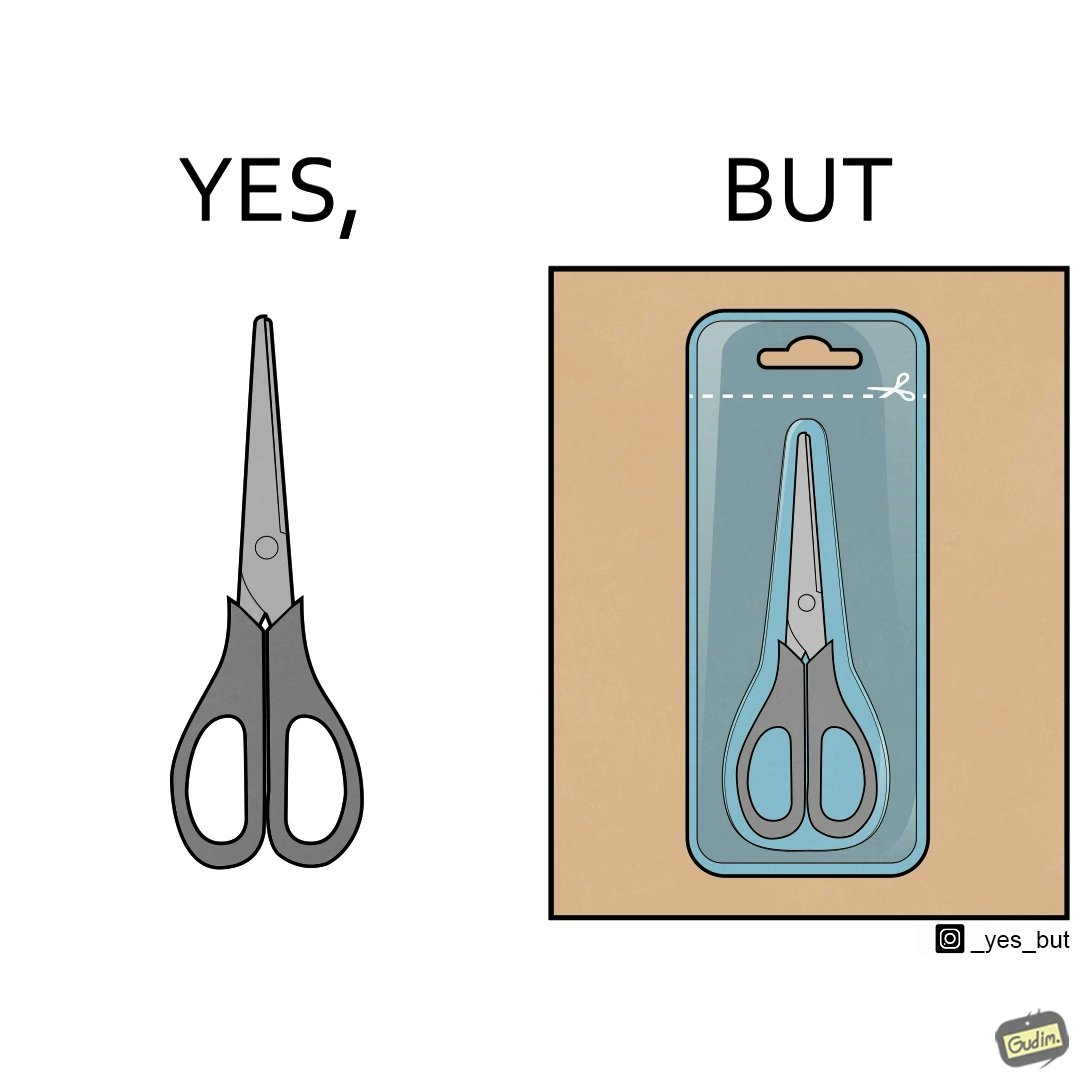Describe what you see in this image. the image is funny, as the marking at the top of the packaging shows that you would need a pair of scissors to in-turn cut open the pair of scissors that is inside the packaging. 